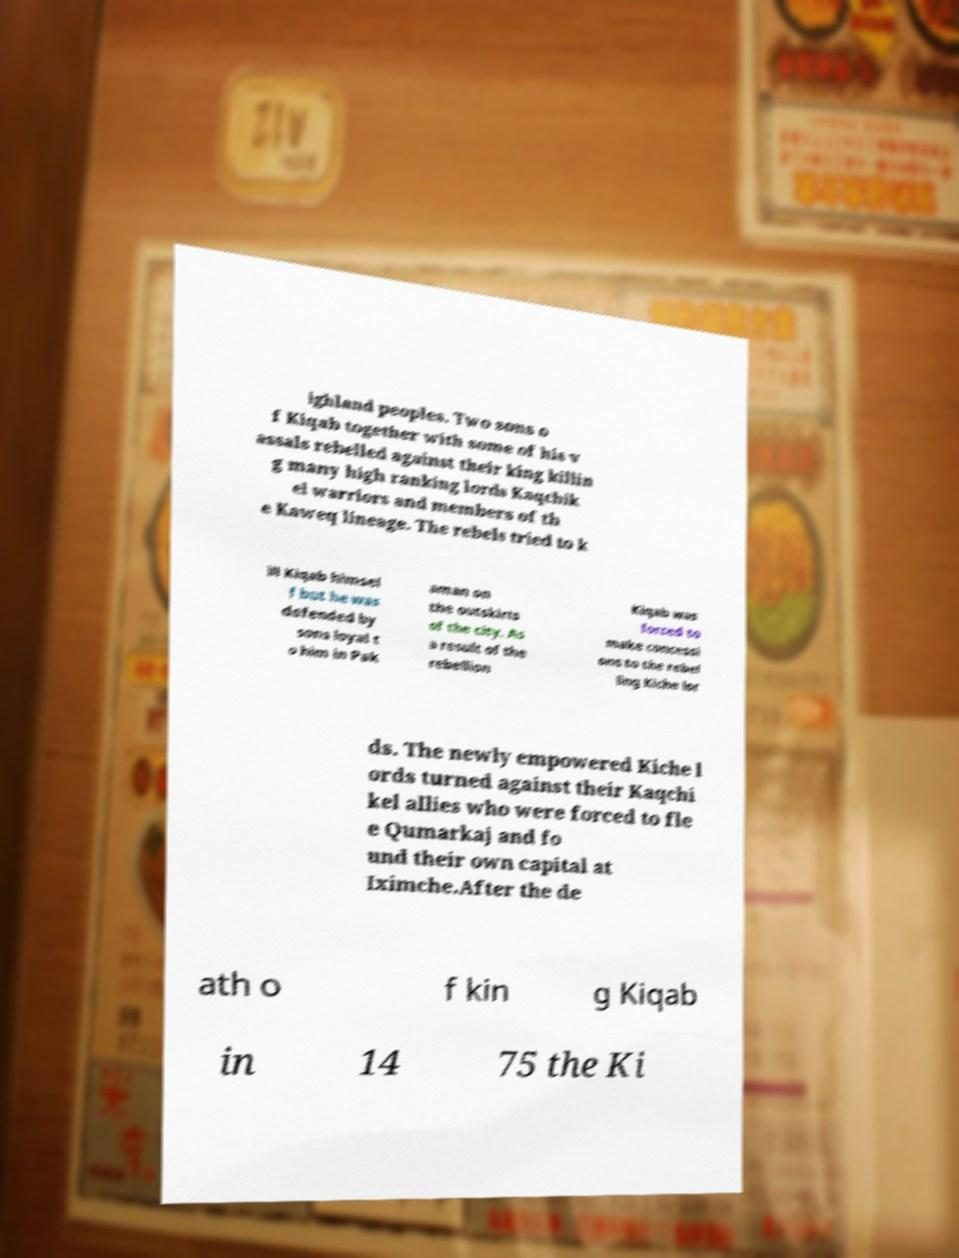Can you read and provide the text displayed in the image?This photo seems to have some interesting text. Can you extract and type it out for me? ighland peoples. Two sons o f Kiqab together with some of his v assals rebelled against their king killin g many high ranking lords Kaqchik el warriors and members of th e Kaweq lineage. The rebels tried to k ill Kiqab himsel f but he was defended by sons loyal t o him in Pak aman on the outskirts of the city. As a result of the rebellion Kiqab was forced to make concessi ons to the rebel ling Kiche lor ds. The newly empowered Kiche l ords turned against their Kaqchi kel allies who were forced to fle e Qumarkaj and fo und their own capital at Iximche.After the de ath o f kin g Kiqab in 14 75 the Ki 